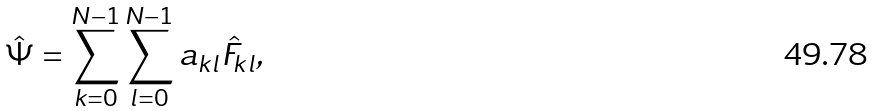<formula> <loc_0><loc_0><loc_500><loc_500>\hat { \Psi } = \sum _ { k = 0 } ^ { N - 1 } \sum _ { l = 0 } ^ { N - 1 } a _ { k l } \hat { F } _ { k l } ,</formula> 